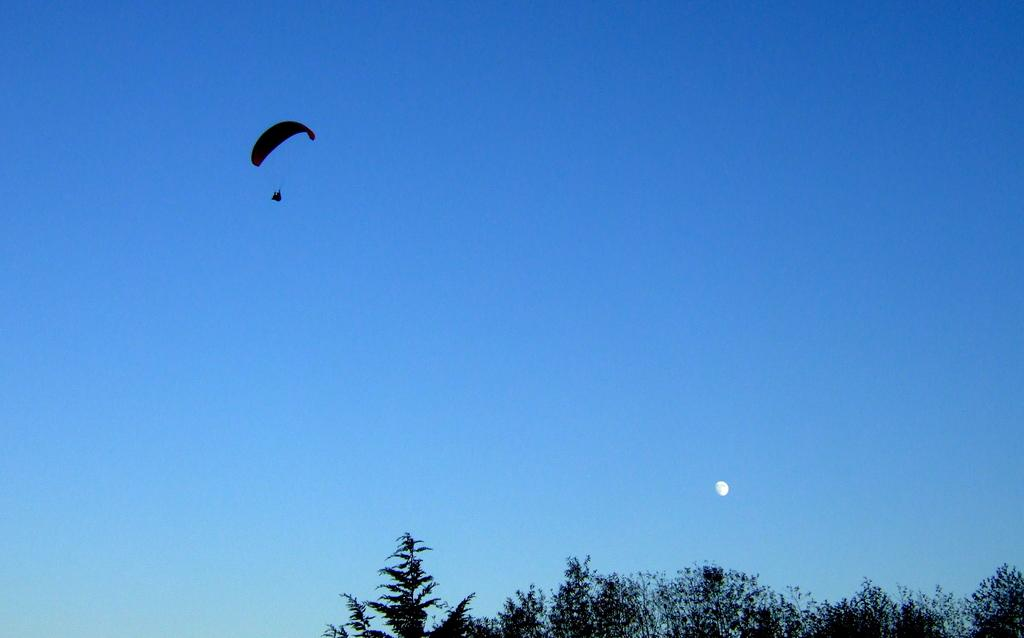What type of vegetation can be seen in the image? There are trees in the image. What activity is the person in the image engaged in? The person is paragliding in the image. What can be seen in the background of the image? The sky and the moon are visible in the background of the image. Can you see a boat navigating through the trees in the image? There is no boat present in the image; it features trees and a person paragliding. What rule is being enforced by the moon in the image? The moon is a celestial body and does not enforce any rules in the image. 